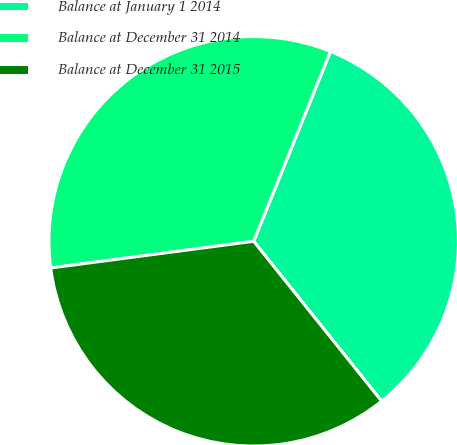Convert chart to OTSL. <chart><loc_0><loc_0><loc_500><loc_500><pie_chart><fcel>Balance at January 1 2014<fcel>Balance at December 31 2014<fcel>Balance at December 31 2015<nl><fcel>33.14%<fcel>33.2%<fcel>33.66%<nl></chart> 